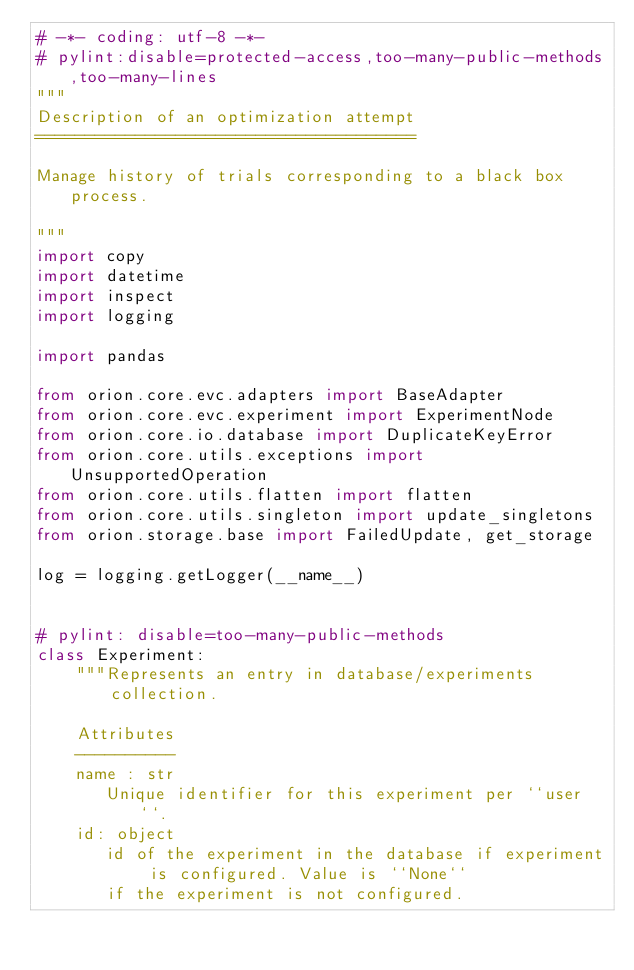<code> <loc_0><loc_0><loc_500><loc_500><_Python_># -*- coding: utf-8 -*-
# pylint:disable=protected-access,too-many-public-methods,too-many-lines
"""
Description of an optimization attempt
======================================

Manage history of trials corresponding to a black box process.

"""
import copy
import datetime
import inspect
import logging

import pandas

from orion.core.evc.adapters import BaseAdapter
from orion.core.evc.experiment import ExperimentNode
from orion.core.io.database import DuplicateKeyError
from orion.core.utils.exceptions import UnsupportedOperation
from orion.core.utils.flatten import flatten
from orion.core.utils.singleton import update_singletons
from orion.storage.base import FailedUpdate, get_storage

log = logging.getLogger(__name__)


# pylint: disable=too-many-public-methods
class Experiment:
    """Represents an entry in database/experiments collection.

    Attributes
    ----------
    name : str
       Unique identifier for this experiment per ``user``.
    id: object
       id of the experiment in the database if experiment is configured. Value is ``None``
       if the experiment is not configured.</code> 